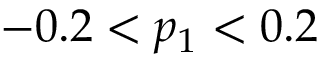Convert formula to latex. <formula><loc_0><loc_0><loc_500><loc_500>- 0 . 2 < p _ { 1 } < 0 . 2</formula> 